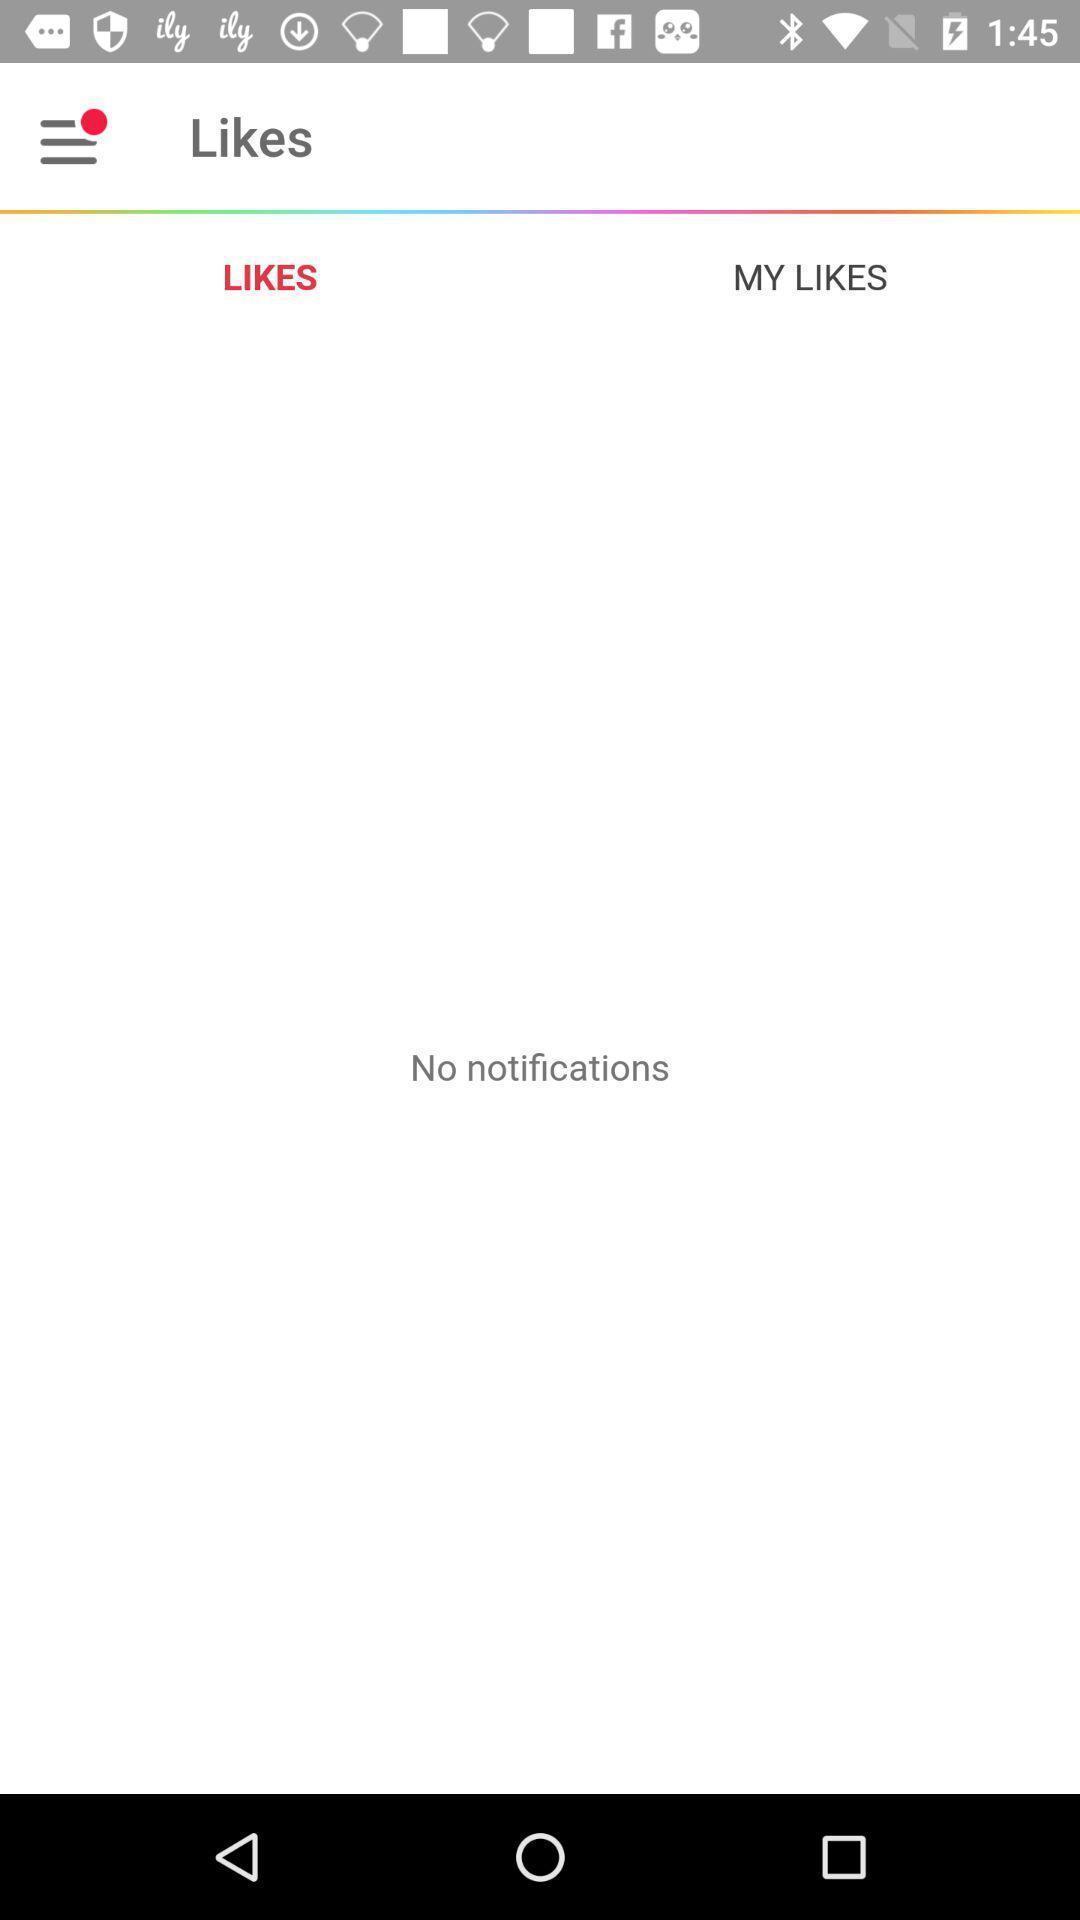Provide a detailed account of this screenshot. Screen displaying multiple options in notifications page. 